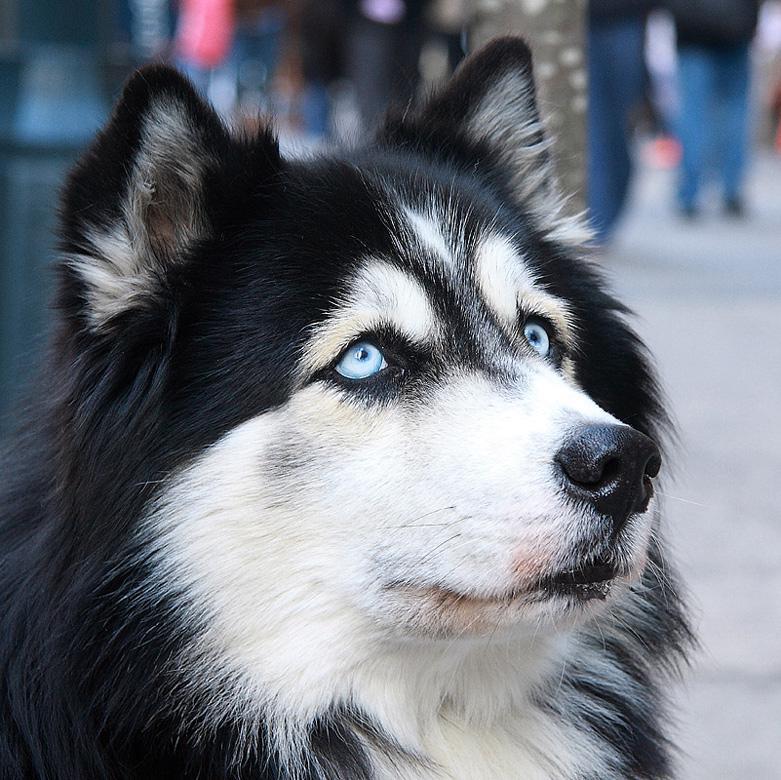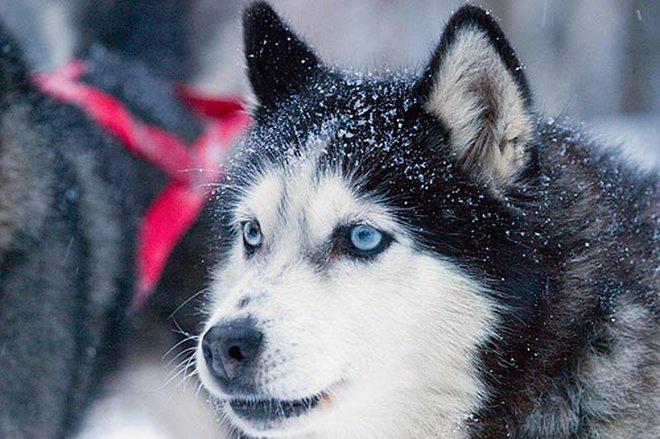The first image is the image on the left, the second image is the image on the right. Evaluate the accuracy of this statement regarding the images: "The right and left image contains the same number of dogs huskeys.". Is it true? Answer yes or no. Yes. 